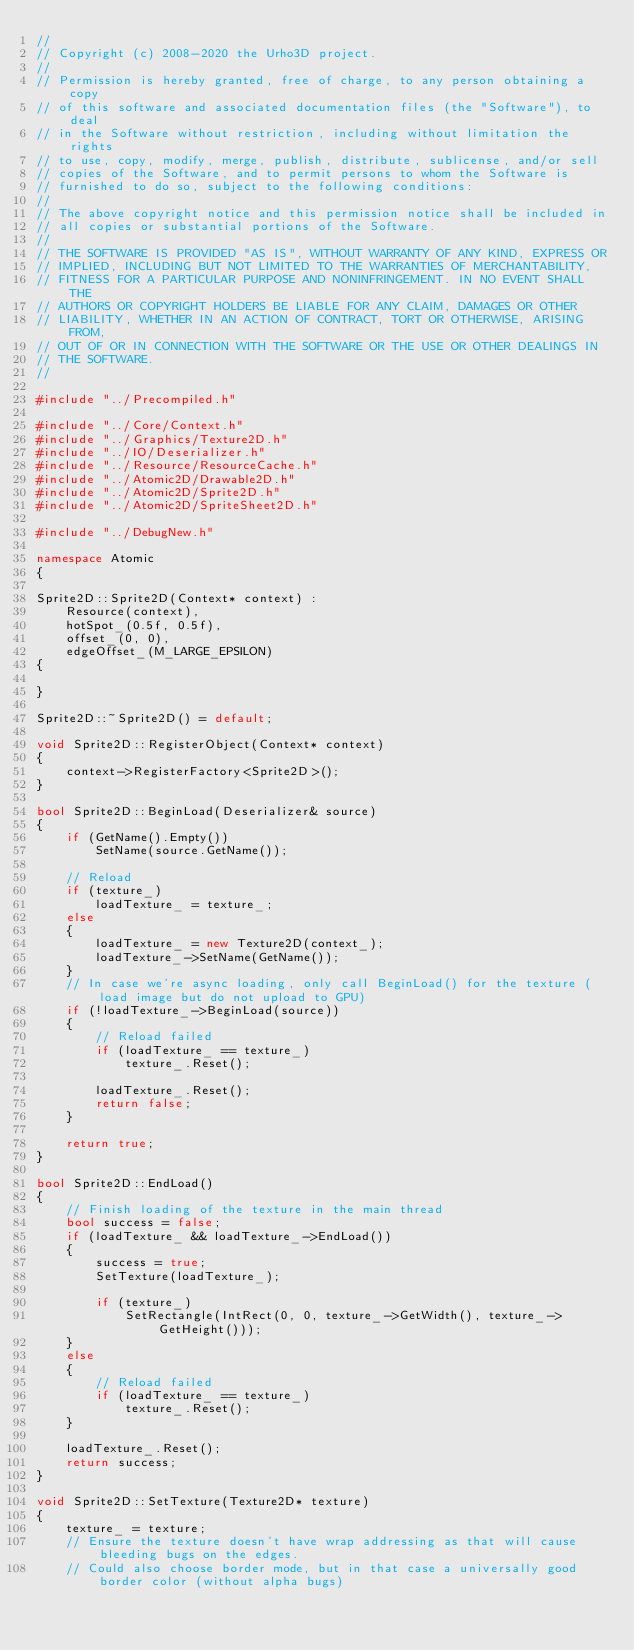Convert code to text. <code><loc_0><loc_0><loc_500><loc_500><_C++_>//
// Copyright (c) 2008-2020 the Urho3D project.
//
// Permission is hereby granted, free of charge, to any person obtaining a copy
// of this software and associated documentation files (the "Software"), to deal
// in the Software without restriction, including without limitation the rights
// to use, copy, modify, merge, publish, distribute, sublicense, and/or sell
// copies of the Software, and to permit persons to whom the Software is
// furnished to do so, subject to the following conditions:
//
// The above copyright notice and this permission notice shall be included in
// all copies or substantial portions of the Software.
//
// THE SOFTWARE IS PROVIDED "AS IS", WITHOUT WARRANTY OF ANY KIND, EXPRESS OR
// IMPLIED, INCLUDING BUT NOT LIMITED TO THE WARRANTIES OF MERCHANTABILITY,
// FITNESS FOR A PARTICULAR PURPOSE AND NONINFRINGEMENT. IN NO EVENT SHALL THE
// AUTHORS OR COPYRIGHT HOLDERS BE LIABLE FOR ANY CLAIM, DAMAGES OR OTHER
// LIABILITY, WHETHER IN AN ACTION OF CONTRACT, TORT OR OTHERWISE, ARISING FROM,
// OUT OF OR IN CONNECTION WITH THE SOFTWARE OR THE USE OR OTHER DEALINGS IN
// THE SOFTWARE.
//

#include "../Precompiled.h"

#include "../Core/Context.h"
#include "../Graphics/Texture2D.h"
#include "../IO/Deserializer.h"
#include "../Resource/ResourceCache.h"
#include "../Atomic2D/Drawable2D.h"
#include "../Atomic2D/Sprite2D.h"
#include "../Atomic2D/SpriteSheet2D.h"

#include "../DebugNew.h"

namespace Atomic
{

Sprite2D::Sprite2D(Context* context) :
    Resource(context),
    hotSpot_(0.5f, 0.5f),
    offset_(0, 0),
    edgeOffset_(M_LARGE_EPSILON)
{

}

Sprite2D::~Sprite2D() = default;

void Sprite2D::RegisterObject(Context* context)
{
    context->RegisterFactory<Sprite2D>();
}

bool Sprite2D::BeginLoad(Deserializer& source)
{
    if (GetName().Empty())
        SetName(source.GetName());

    // Reload
    if (texture_)
        loadTexture_ = texture_;
    else
    {
        loadTexture_ = new Texture2D(context_);
        loadTexture_->SetName(GetName());
    }
    // In case we're async loading, only call BeginLoad() for the texture (load image but do not upload to GPU)
    if (!loadTexture_->BeginLoad(source))
    {
        // Reload failed
        if (loadTexture_ == texture_)
            texture_.Reset();

        loadTexture_.Reset();
        return false;
    }

    return true;
}

bool Sprite2D::EndLoad()
{
    // Finish loading of the texture in the main thread
    bool success = false;
    if (loadTexture_ && loadTexture_->EndLoad())
    {
        success = true;
        SetTexture(loadTexture_);

        if (texture_)
            SetRectangle(IntRect(0, 0, texture_->GetWidth(), texture_->GetHeight()));
    }
    else
    {
        // Reload failed
        if (loadTexture_ == texture_)
            texture_.Reset();
    }

    loadTexture_.Reset();
    return success;
}

void Sprite2D::SetTexture(Texture2D* texture)
{
    texture_ = texture;
    // Ensure the texture doesn't have wrap addressing as that will cause bleeding bugs on the edges.
    // Could also choose border mode, but in that case a universally good border color (without alpha bugs)</code> 